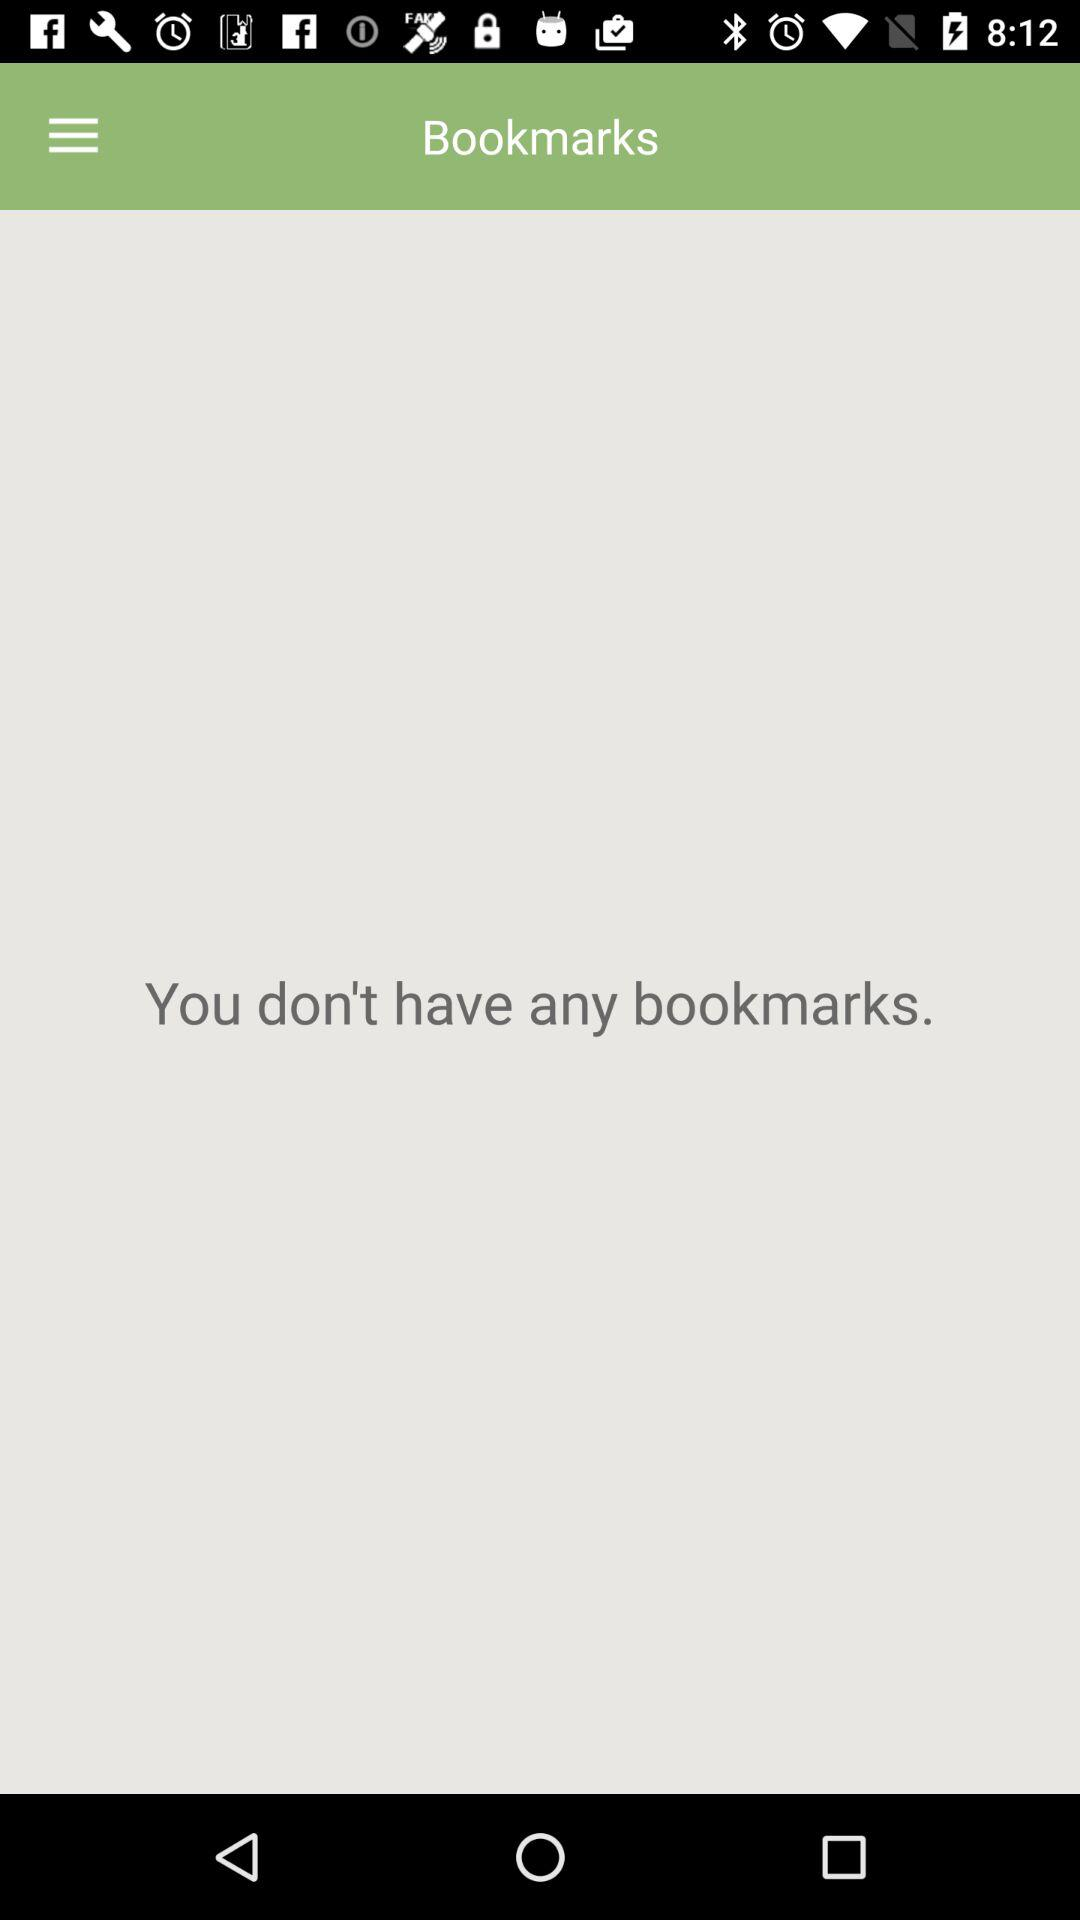How many bookmarks do I not have?
Answer the question using a single word or phrase. 0 